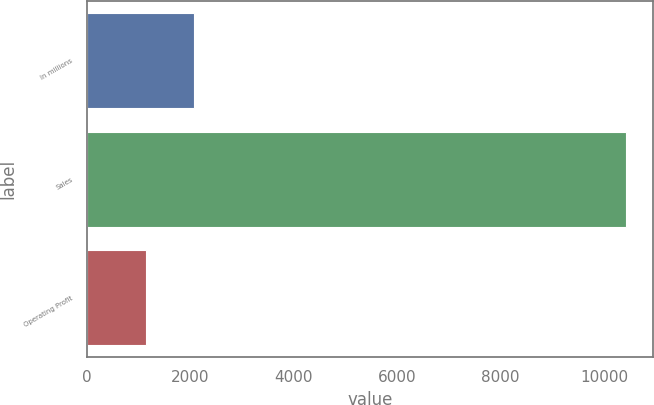<chart> <loc_0><loc_0><loc_500><loc_500><bar_chart><fcel>In millions<fcel>Sales<fcel>Operating Profit<nl><fcel>2075.3<fcel>10430<fcel>1147<nl></chart> 